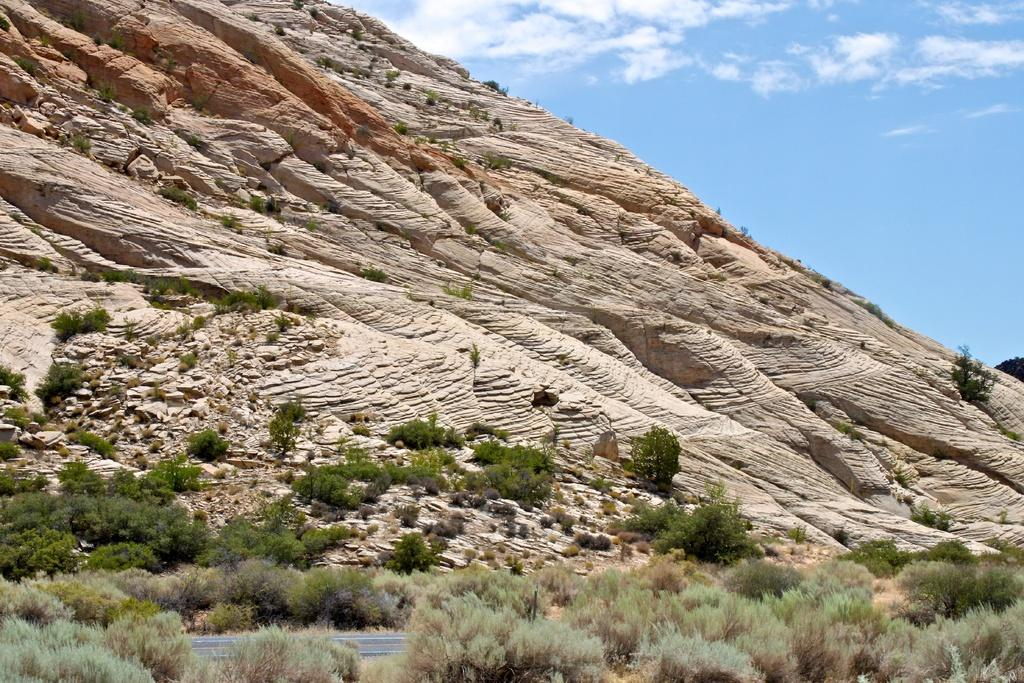What type of vegetation can be seen in the image? There are trees in the image. What geographical feature is present in the image? There is a hill in the image. What can be seen in the sky in the image? There are clouds visible in the image. How does the pump function in the image? There is no pump present in the image. What is the limit of the clouds in the image? The image does not specify a limit for the clouds; they are simply visible in the sky. 